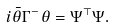<formula> <loc_0><loc_0><loc_500><loc_500>i \bar { \theta } \Gamma ^ { - } \theta = \Psi ^ { \top } \Psi .</formula> 